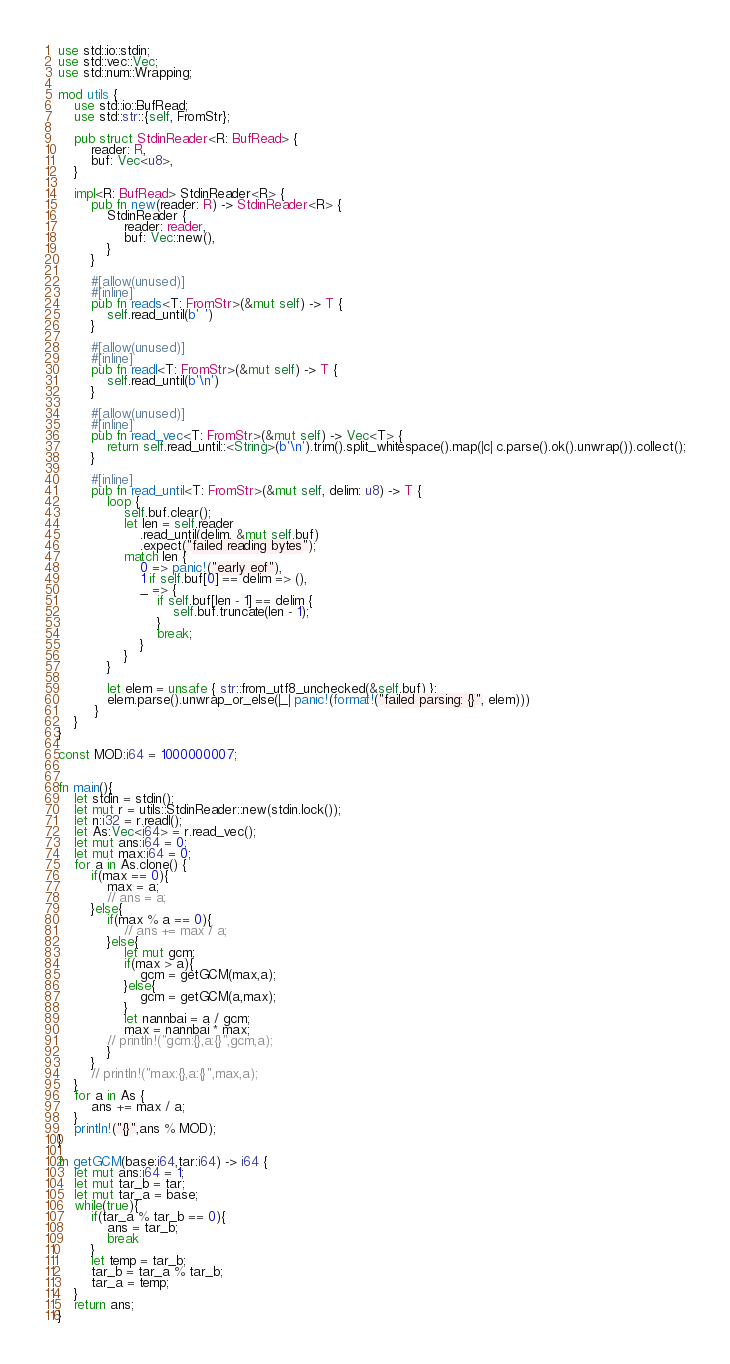<code> <loc_0><loc_0><loc_500><loc_500><_Rust_>use std::io::stdin;
use std::vec::Vec;
use std::num::Wrapping;

mod utils {
    use std::io::BufRead;
    use std::str::{self, FromStr};

    pub struct StdinReader<R: BufRead> {
        reader: R,
        buf: Vec<u8>,
    }

    impl<R: BufRead> StdinReader<R> {
        pub fn new(reader: R) -> StdinReader<R> {
            StdinReader {
                reader: reader,
                buf: Vec::new(),
            }
        }

        #[allow(unused)]
        #[inline]
        pub fn reads<T: FromStr>(&mut self) -> T {
            self.read_until(b' ')
        }

        #[allow(unused)]
        #[inline]
        pub fn readl<T: FromStr>(&mut self) -> T {
            self.read_until(b'\n')
        }

        #[allow(unused)]
        #[inline]
        pub fn read_vec<T: FromStr>(&mut self) -> Vec<T> {
            return self.read_until::<String>(b'\n').trim().split_whitespace().map(|c| c.parse().ok().unwrap()).collect();
        }

        #[inline]
        pub fn read_until<T: FromStr>(&mut self, delim: u8) -> T {
            loop {
                self.buf.clear();
                let len = self.reader
                    .read_until(delim, &mut self.buf)
                    .expect("failed reading bytes");
                match len {
                    0 => panic!("early eof"),
                    1 if self.buf[0] == delim => (),
                    _ => {
                        if self.buf[len - 1] == delim {
                            self.buf.truncate(len - 1);
                        }
                        break;
                    }
                }
            }

            let elem = unsafe { str::from_utf8_unchecked(&self.buf) };
            elem.parse().unwrap_or_else(|_| panic!(format!("failed parsing: {}", elem)))
         }
    }
}

const MOD:i64 = 1000000007;


fn main(){
    let stdin = stdin();
    let mut r = utils::StdinReader::new(stdin.lock());
    let n:i32 = r.readl();
    let As:Vec<i64> = r.read_vec();
    let mut ans:i64 = 0;
    let mut max:i64 = 0;
    for a in As.clone() {
        if(max == 0){
            max = a;
            // ans = a;
        }else{
            if(max % a == 0){
                // ans += max / a;
            }else{
                let mut gcm;
                if(max > a){
                    gcm = getGCM(max,a);
                }else{
                    gcm = getGCM(a,max);
                }
                let nannbai = a / gcm;
                max = nannbai * max;
            // println!("gcm:{},a:{}",gcm,a);
            }
        }
        // println!("max:{},a:{}",max,a);
    }
    for a in As {
        ans += max / a;
    }
    println!("{}",ans % MOD);
}

fn getGCM(base:i64,tar:i64) -> i64 {
    let mut ans:i64 = 1;
    let mut tar_b = tar;
    let mut tar_a = base;
    while(true){
        if(tar_a % tar_b == 0){
            ans = tar_b;
            break
        }
        let temp = tar_b;
        tar_b = tar_a % tar_b;
        tar_a = temp;
    }
    return ans;
}
</code> 